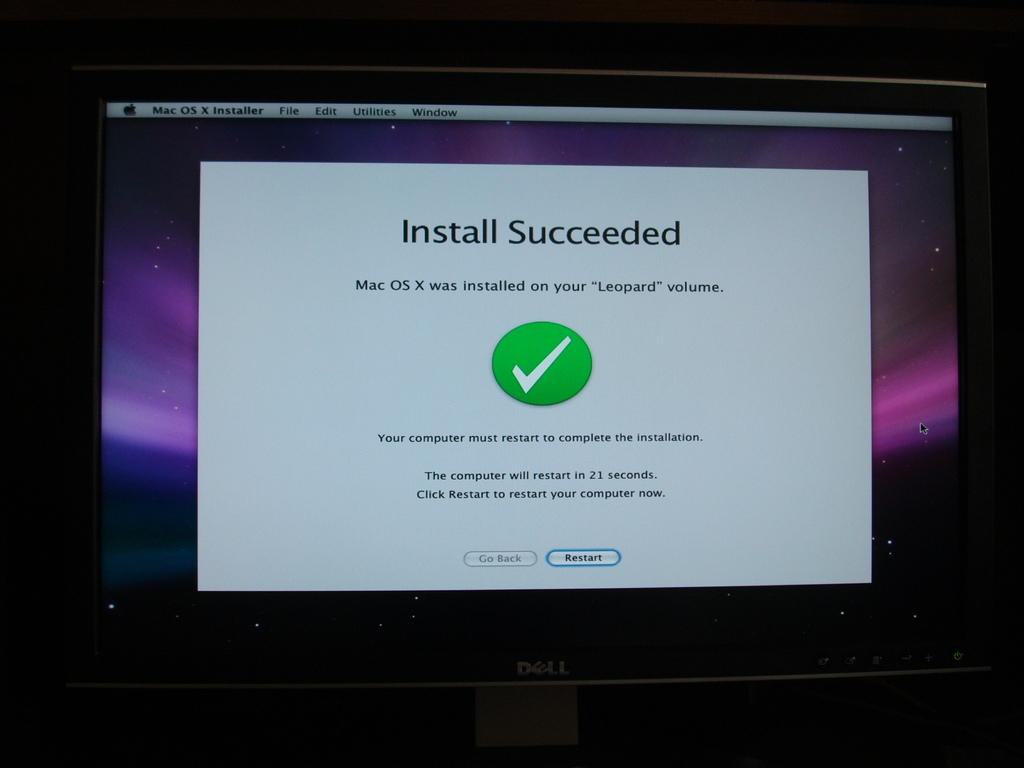<image>
Write a terse but informative summary of the picture. Screen with a green check mark telling the user the Install Succeeded. 